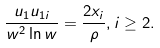Convert formula to latex. <formula><loc_0><loc_0><loc_500><loc_500>\frac { u _ { 1 } u _ { 1 i } } { w ^ { 2 } \ln w } = \frac { 2 x _ { i } } { \rho } , i \geq 2 .</formula> 